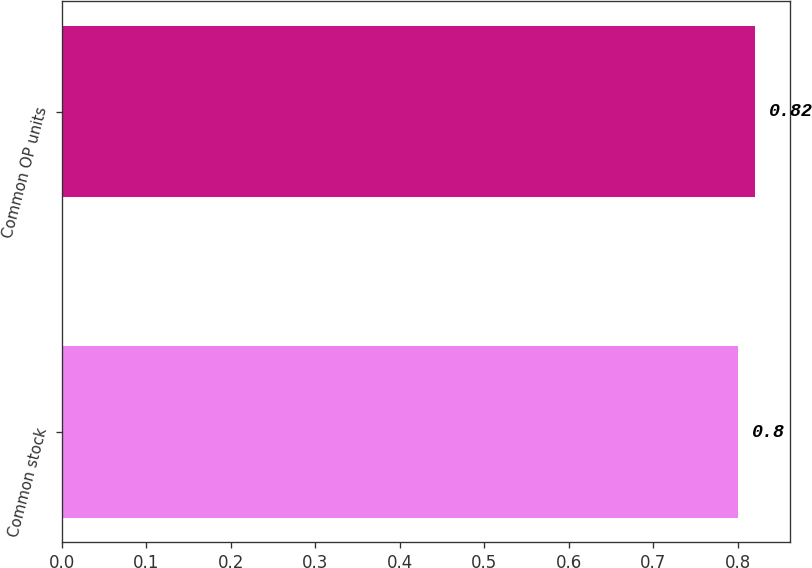Convert chart. <chart><loc_0><loc_0><loc_500><loc_500><bar_chart><fcel>Common stock<fcel>Common OP units<nl><fcel>0.8<fcel>0.82<nl></chart> 